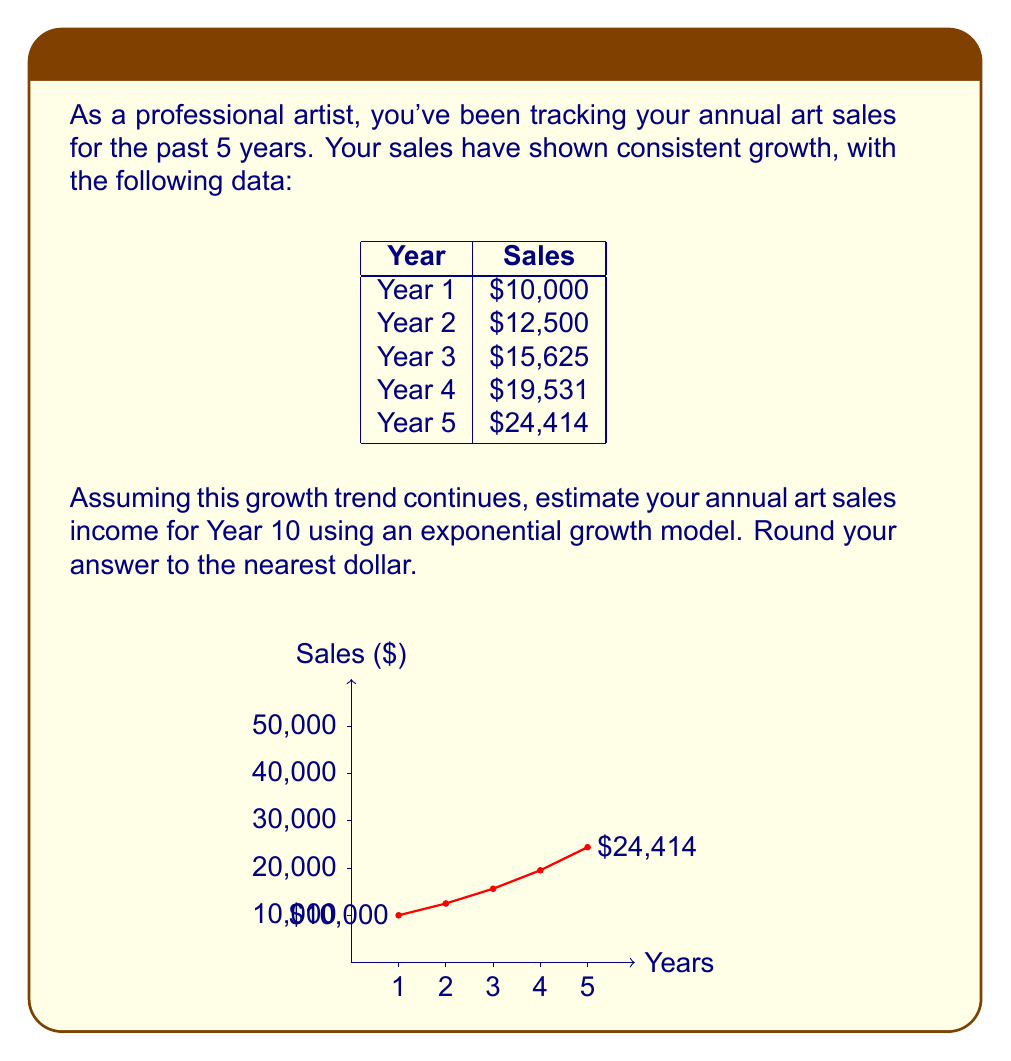What is the answer to this math problem? To solve this problem, we'll use the exponential growth model:

$$A = P(1 + r)^t$$

Where:
$A$ = Final amount
$P$ = Initial principal balance
$r$ = Growth rate (as a decimal)
$t$ = Number of time periods

Step 1: Calculate the growth rate
We can see that each year's sales are 1.25 times the previous year's sales.
Growth rate = 25% = 0.25

Step 2: Set up the equation
Initial amount (Year 1): $P = 10,000$
Growth rate: $r = 0.25$
Time periods (from Year 5 to Year 10): $t = 5$

$$A = 10,000(1 + 0.25)^{5+5}$$

Step 3: Simplify and calculate
$$A = 10,000(1.25)^{10}$$
$$A = 10,000 \times 9.3132...$$
$$A = 93,132.26...$$

Step 4: Round to the nearest dollar
$A \approx 93,132$

Therefore, the estimated annual art sales income for Year 10 is $93,132.
Answer: $93,132 